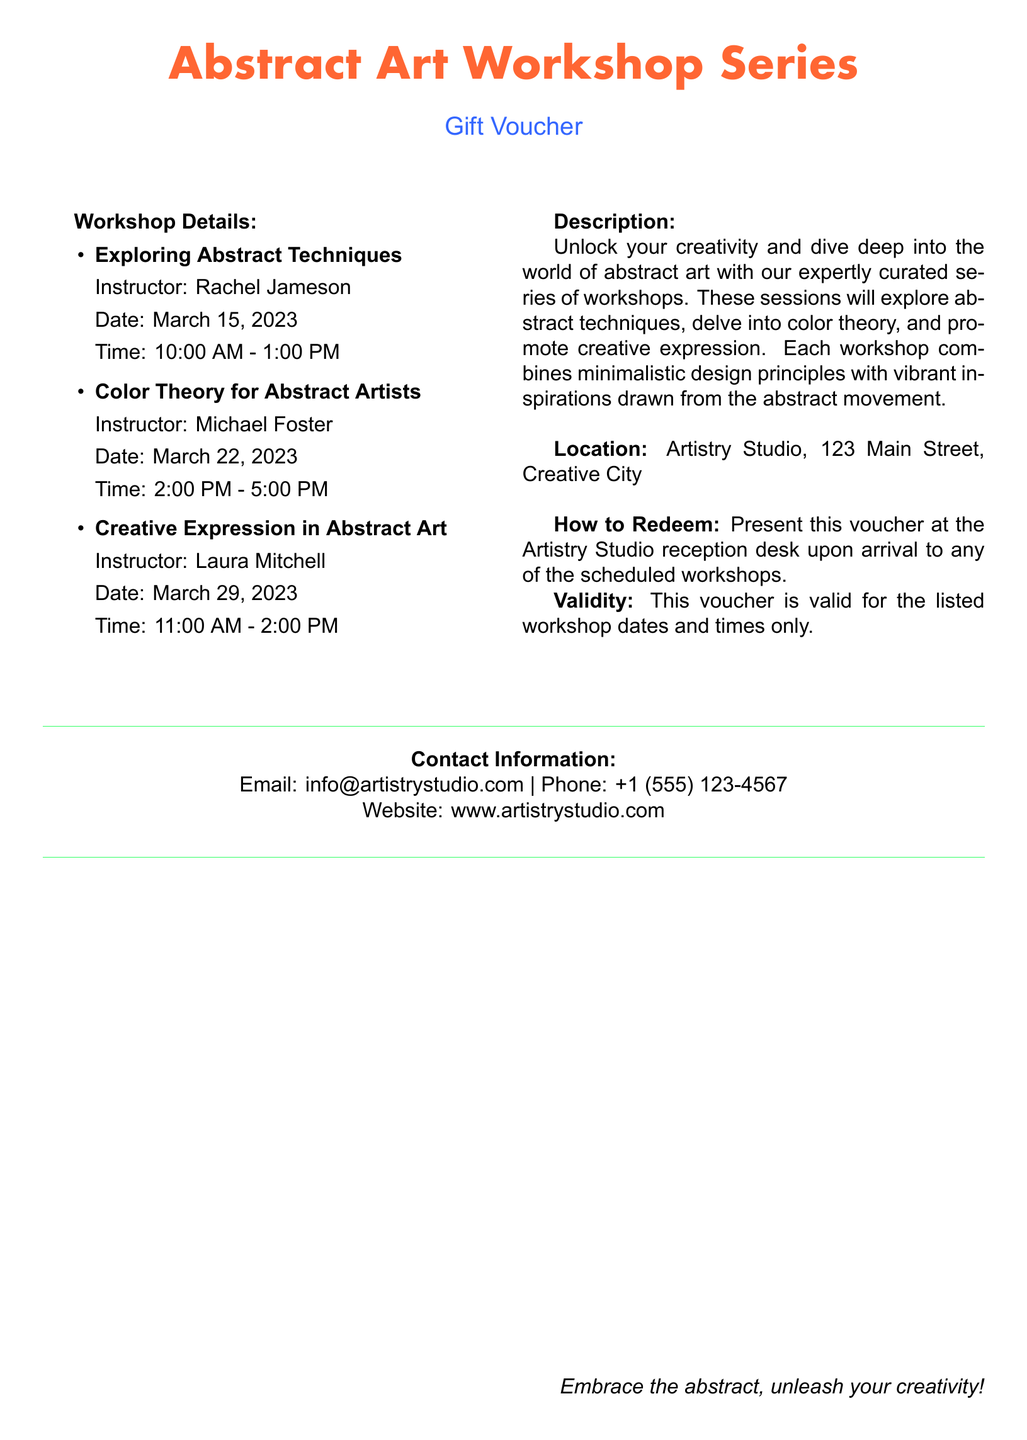What is the title of the workshop series? The title of the workshop series is provided at the top of the document in a bold font.
Answer: Abstract Art Workshop Series Who is the instructor for the Color Theory workshop? The instructor's name for the Color Theory workshop is listed next to the workshop title in the details section.
Answer: Michael Foster What is the date for the Exploring Abstract Techniques workshop? The date for the workshop is specified directly below the workshop title in the details section.
Answer: March 15, 2023 What time does the Creative Expression workshop start? The start time for the workshop is indicated in the details section next to the workshop title.
Answer: 11:00 AM Where is the location of the workshops? The location is stated in the description section of the document.
Answer: Artistry Studio, 123 Main Street, Creative City How can the voucher be redeemed? The redemption method is outlined clearly in the document's How to Redeem section.
Answer: Present this voucher at the Artistry Studio reception desk What is the validity of the voucher? The validity statement specifies the terms of use for the voucher.
Answer: Valid for the listed workshop dates and times only How many workshops are included in the series? The number of workshops is indicated by the list of sessions in the Workshop Details section.
Answer: Three 